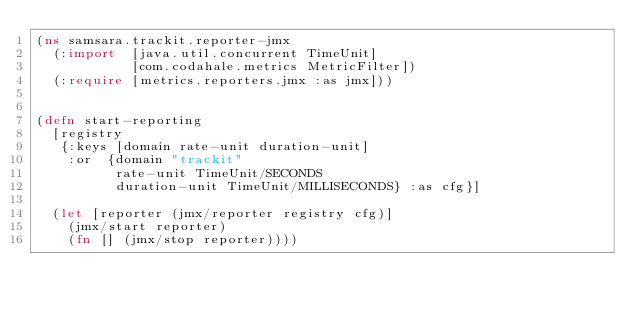Convert code to text. <code><loc_0><loc_0><loc_500><loc_500><_Clojure_>(ns samsara.trackit.reporter-jmx
  (:import  [java.util.concurrent TimeUnit]
            [com.codahale.metrics MetricFilter])
  (:require [metrics.reporters.jmx :as jmx]))


(defn start-reporting
  [registry
   {:keys [domain rate-unit duration-unit]
    :or  {domain "trackit"
          rate-unit TimeUnit/SECONDS
          duration-unit TimeUnit/MILLISECONDS} :as cfg}]

  (let [reporter (jmx/reporter registry cfg)]
    (jmx/start reporter)
    (fn [] (jmx/stop reporter))))
</code> 